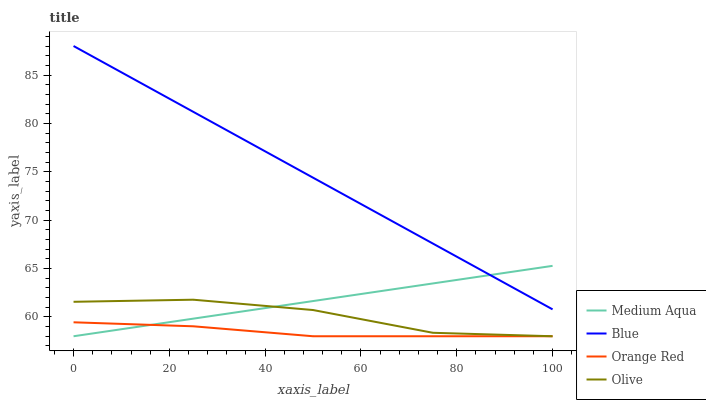Does Orange Red have the minimum area under the curve?
Answer yes or no. Yes. Does Blue have the maximum area under the curve?
Answer yes or no. Yes. Does Olive have the minimum area under the curve?
Answer yes or no. No. Does Olive have the maximum area under the curve?
Answer yes or no. No. Is Medium Aqua the smoothest?
Answer yes or no. Yes. Is Olive the roughest?
Answer yes or no. Yes. Is Olive the smoothest?
Answer yes or no. No. Is Medium Aqua the roughest?
Answer yes or no. No. Does Olive have the lowest value?
Answer yes or no. Yes. Does Blue have the highest value?
Answer yes or no. Yes. Does Olive have the highest value?
Answer yes or no. No. Is Orange Red less than Blue?
Answer yes or no. Yes. Is Blue greater than Orange Red?
Answer yes or no. Yes. Does Olive intersect Orange Red?
Answer yes or no. Yes. Is Olive less than Orange Red?
Answer yes or no. No. Is Olive greater than Orange Red?
Answer yes or no. No. Does Orange Red intersect Blue?
Answer yes or no. No. 